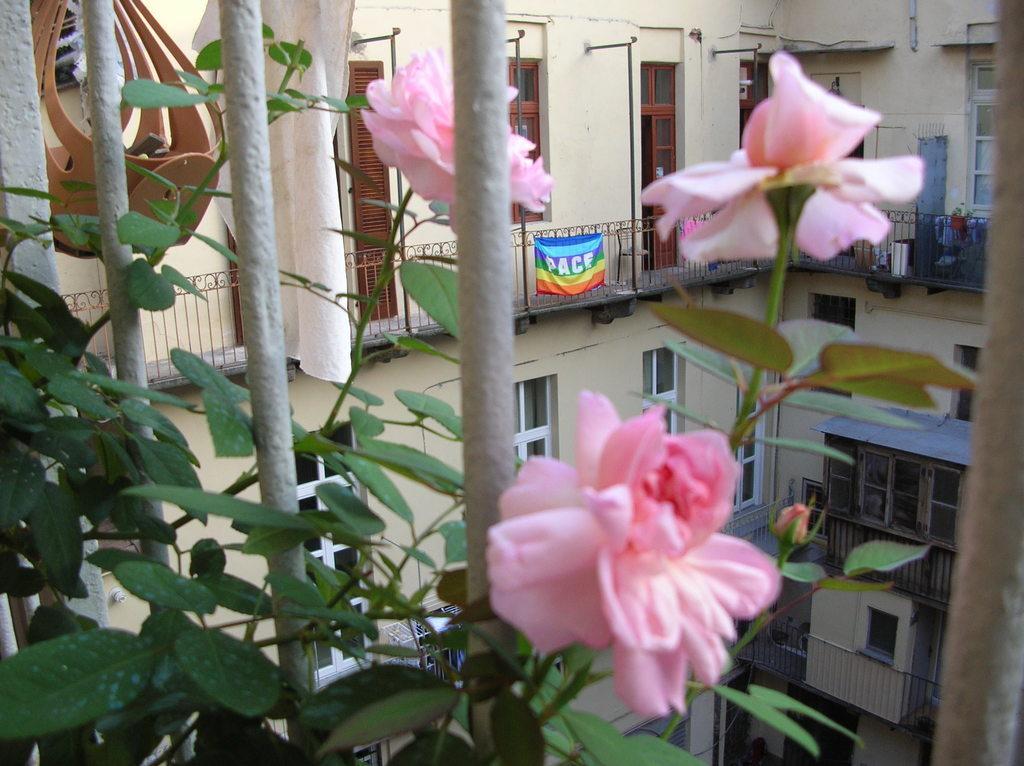How would you summarize this image in a sentence or two? n this image, in the left corner, we can see some plants. In the middle of the image, we can see some flowers which are pink in color. On the right side, we can see a wood rod. In the background, we can see a building, glass window, hoardings, doors, metal rod, wall. 